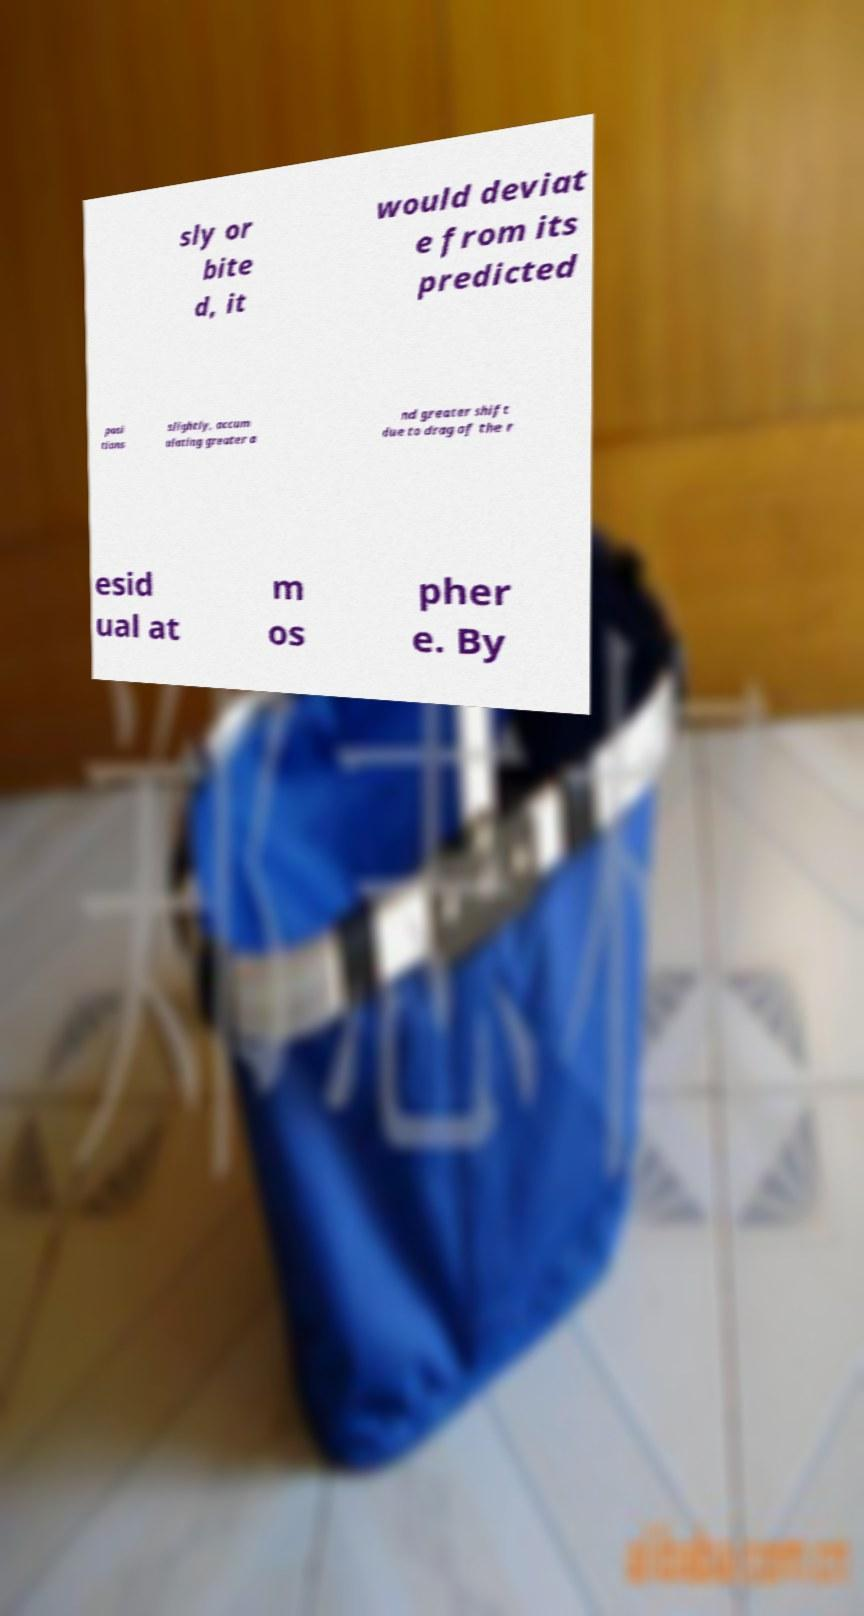Can you read and provide the text displayed in the image?This photo seems to have some interesting text. Can you extract and type it out for me? sly or bite d, it would deviat e from its predicted posi tions slightly, accum ulating greater a nd greater shift due to drag of the r esid ual at m os pher e. By 